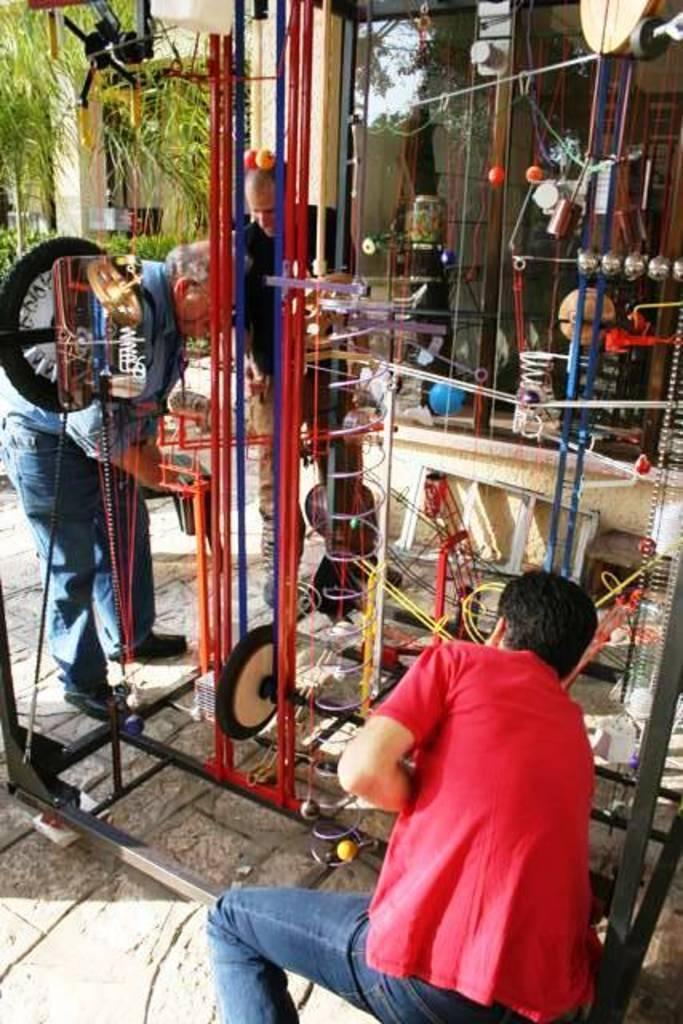Please provide a concise description of this image. In this image there are persons standing and in the center there is a stand. In the background there are leaves and there are objects which are blue, red and white in colour and there is a pillar. In the front there are wheels and there are ropes. 